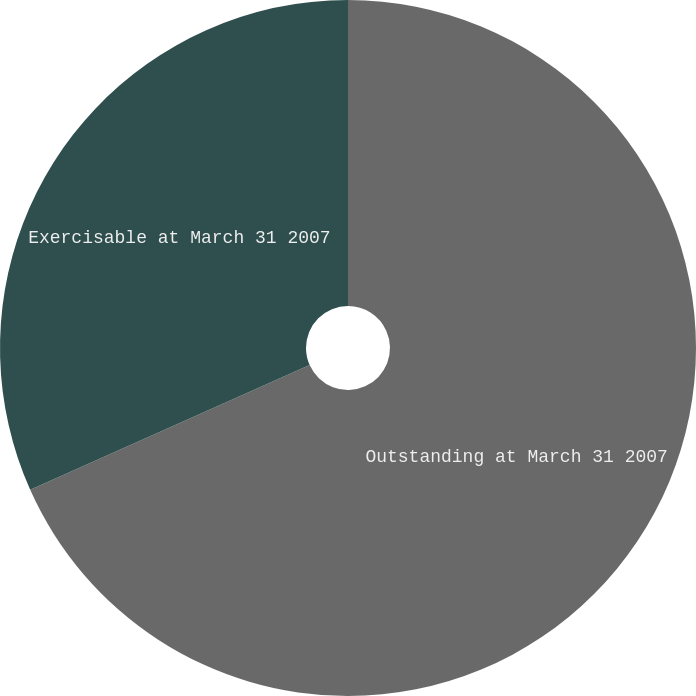Convert chart. <chart><loc_0><loc_0><loc_500><loc_500><pie_chart><fcel>Outstanding at March 31 2007<fcel>Exercisable at March 31 2007<nl><fcel>68.32%<fcel>31.68%<nl></chart> 